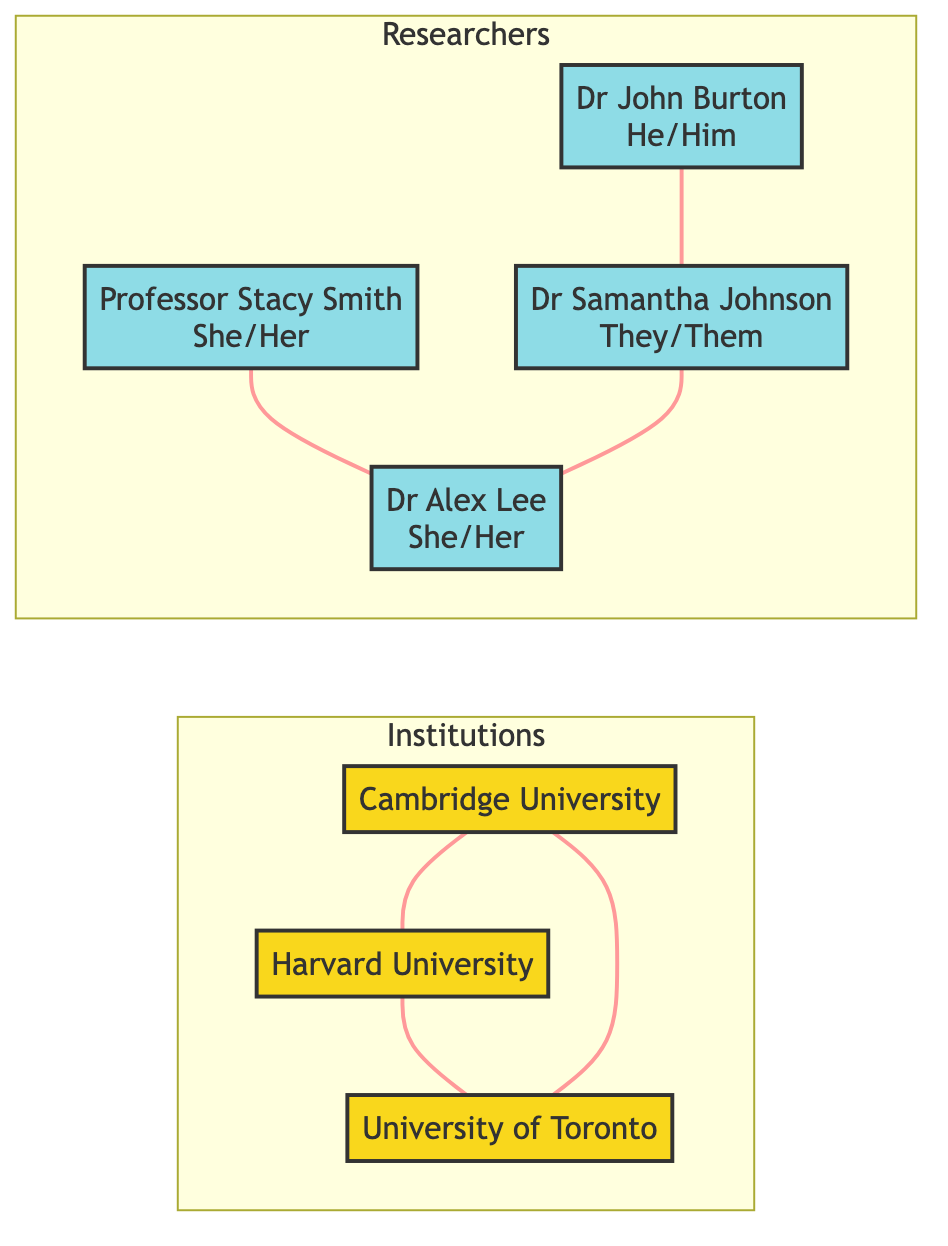What institutions are represented in the diagram? The nodes representing institutions are identified as Cambridge University, Harvard University, and University of Toronto. Each of these nodes is visibly labeled in the diagram.
Answer: Cambridge University, Harvard University, University of Toronto How many lead researchers are shown in the diagram? Counting the nodes labeled as lead researchers, we find four: Professor Stacy Smith, Dr. John Burton, Dr. Samantha Johnson, and Dr. Alex Lee. This can be determined by identifying the nodes categorized under Researchers.
Answer: 4 What is the relationship between Harvard University and University of Toronto? The relationship between these two nodes is labeled as Research Collaboration. This information can be found by examining the edges connecting the nodes Harvard University and University of Toronto.
Answer: Research Collaboration Which researcher is associated with the University of Southern California? The node representing Professor Stacy Smith is the only one linked with the University of Southern California. This can be extracted from the details provided in her associated institution label.
Answer: Professor Stacy Smith How many research collaborations are represented in total? By counting the edges labeled as Research Collaboration in the diagram, we find there are three distinct collaborations involving the institutions shown.
Answer: 3 Which researchers collaborate with Dr. Samantha Johnson? The collaborators identified with Dr. Samantha Johnson are Dr. John Burton and Dr. Alex Lee, visible through the connecting edges labeled Co-Researcher.
Answer: Dr. John Burton, Dr. Alex Lee Is there a researcher who uses they/them pronouns? Yes, Dr. Samantha Johnson is explicitly noted as using they/them pronouns, which can be confirmed by checking the gender pronouns associated with each researcher node.
Answer: Dr. Samantha Johnson What is the connection between Cambridge University and Harvard University? The connection is specified as Research Collaboration, identifiable through the edge connecting these two institutions in the diagram.
Answer: Research Collaboration Which researcher has the pronouns she/her and is linked with the University of Toronto? Dr. Alex Lee is the researcher linked with the University of Toronto and has the pronouns she/her. This information is found by noting both the associated institution and the gender pronouns in her node.
Answer: Dr. Alex Lee 